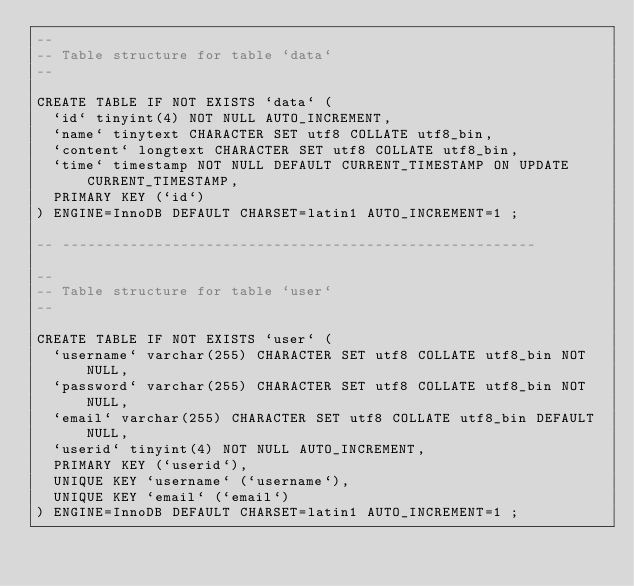<code> <loc_0><loc_0><loc_500><loc_500><_SQL_>--
-- Table structure for table `data`
--

CREATE TABLE IF NOT EXISTS `data` (
  `id` tinyint(4) NOT NULL AUTO_INCREMENT,
  `name` tinytext CHARACTER SET utf8 COLLATE utf8_bin,
  `content` longtext CHARACTER SET utf8 COLLATE utf8_bin,
  `time` timestamp NOT NULL DEFAULT CURRENT_TIMESTAMP ON UPDATE CURRENT_TIMESTAMP,
  PRIMARY KEY (`id`)
) ENGINE=InnoDB DEFAULT CHARSET=latin1 AUTO_INCREMENT=1 ;

-- --------------------------------------------------------

--
-- Table structure for table `user`
--

CREATE TABLE IF NOT EXISTS `user` (
  `username` varchar(255) CHARACTER SET utf8 COLLATE utf8_bin NOT NULL,
  `password` varchar(255) CHARACTER SET utf8 COLLATE utf8_bin NOT NULL,
  `email` varchar(255) CHARACTER SET utf8 COLLATE utf8_bin DEFAULT NULL,
  `userid` tinyint(4) NOT NULL AUTO_INCREMENT,
  PRIMARY KEY (`userid`),
  UNIQUE KEY `username` (`username`),
  UNIQUE KEY `email` (`email`)
) ENGINE=InnoDB DEFAULT CHARSET=latin1 AUTO_INCREMENT=1 ;
</code> 